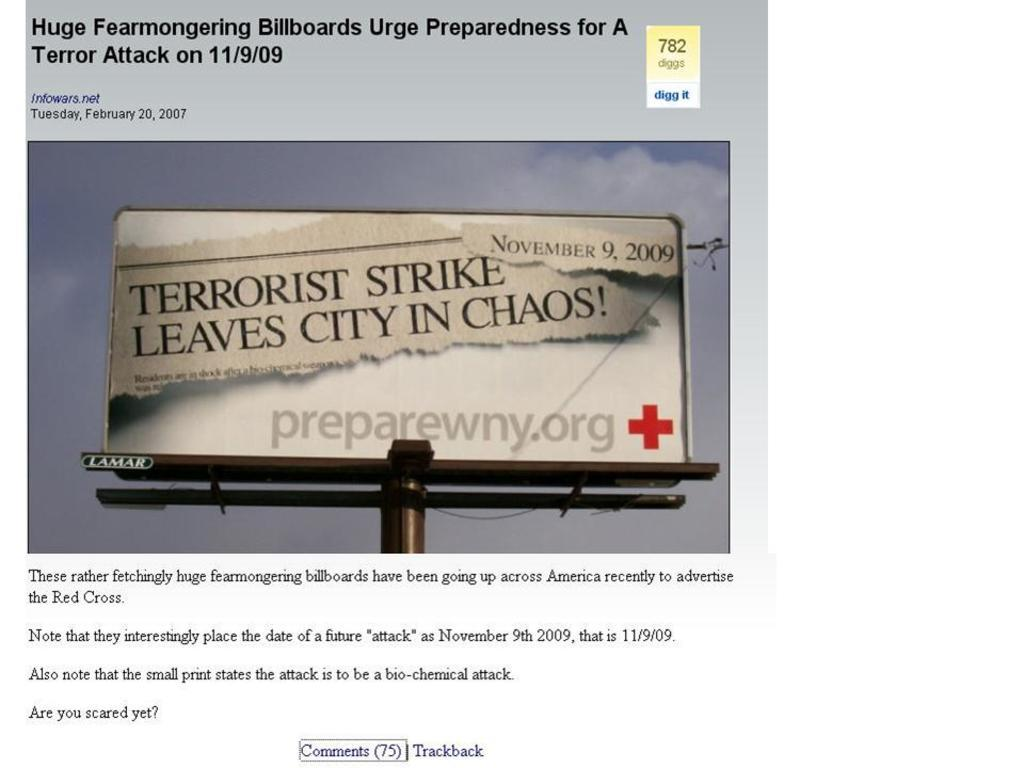<image>
Create a compact narrative representing the image presented. Banner with terrorist strike leaves city in chaos sign 